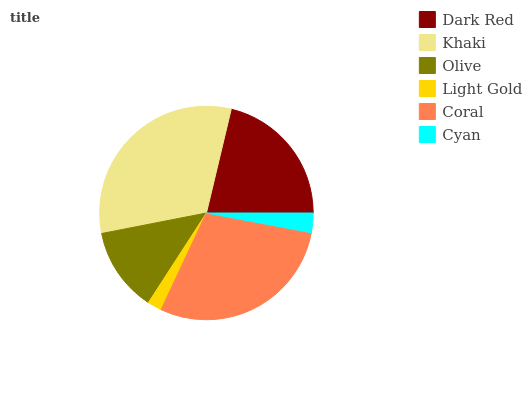Is Light Gold the minimum?
Answer yes or no. Yes. Is Khaki the maximum?
Answer yes or no. Yes. Is Olive the minimum?
Answer yes or no. No. Is Olive the maximum?
Answer yes or no. No. Is Khaki greater than Olive?
Answer yes or no. Yes. Is Olive less than Khaki?
Answer yes or no. Yes. Is Olive greater than Khaki?
Answer yes or no. No. Is Khaki less than Olive?
Answer yes or no. No. Is Dark Red the high median?
Answer yes or no. Yes. Is Olive the low median?
Answer yes or no. Yes. Is Olive the high median?
Answer yes or no. No. Is Light Gold the low median?
Answer yes or no. No. 